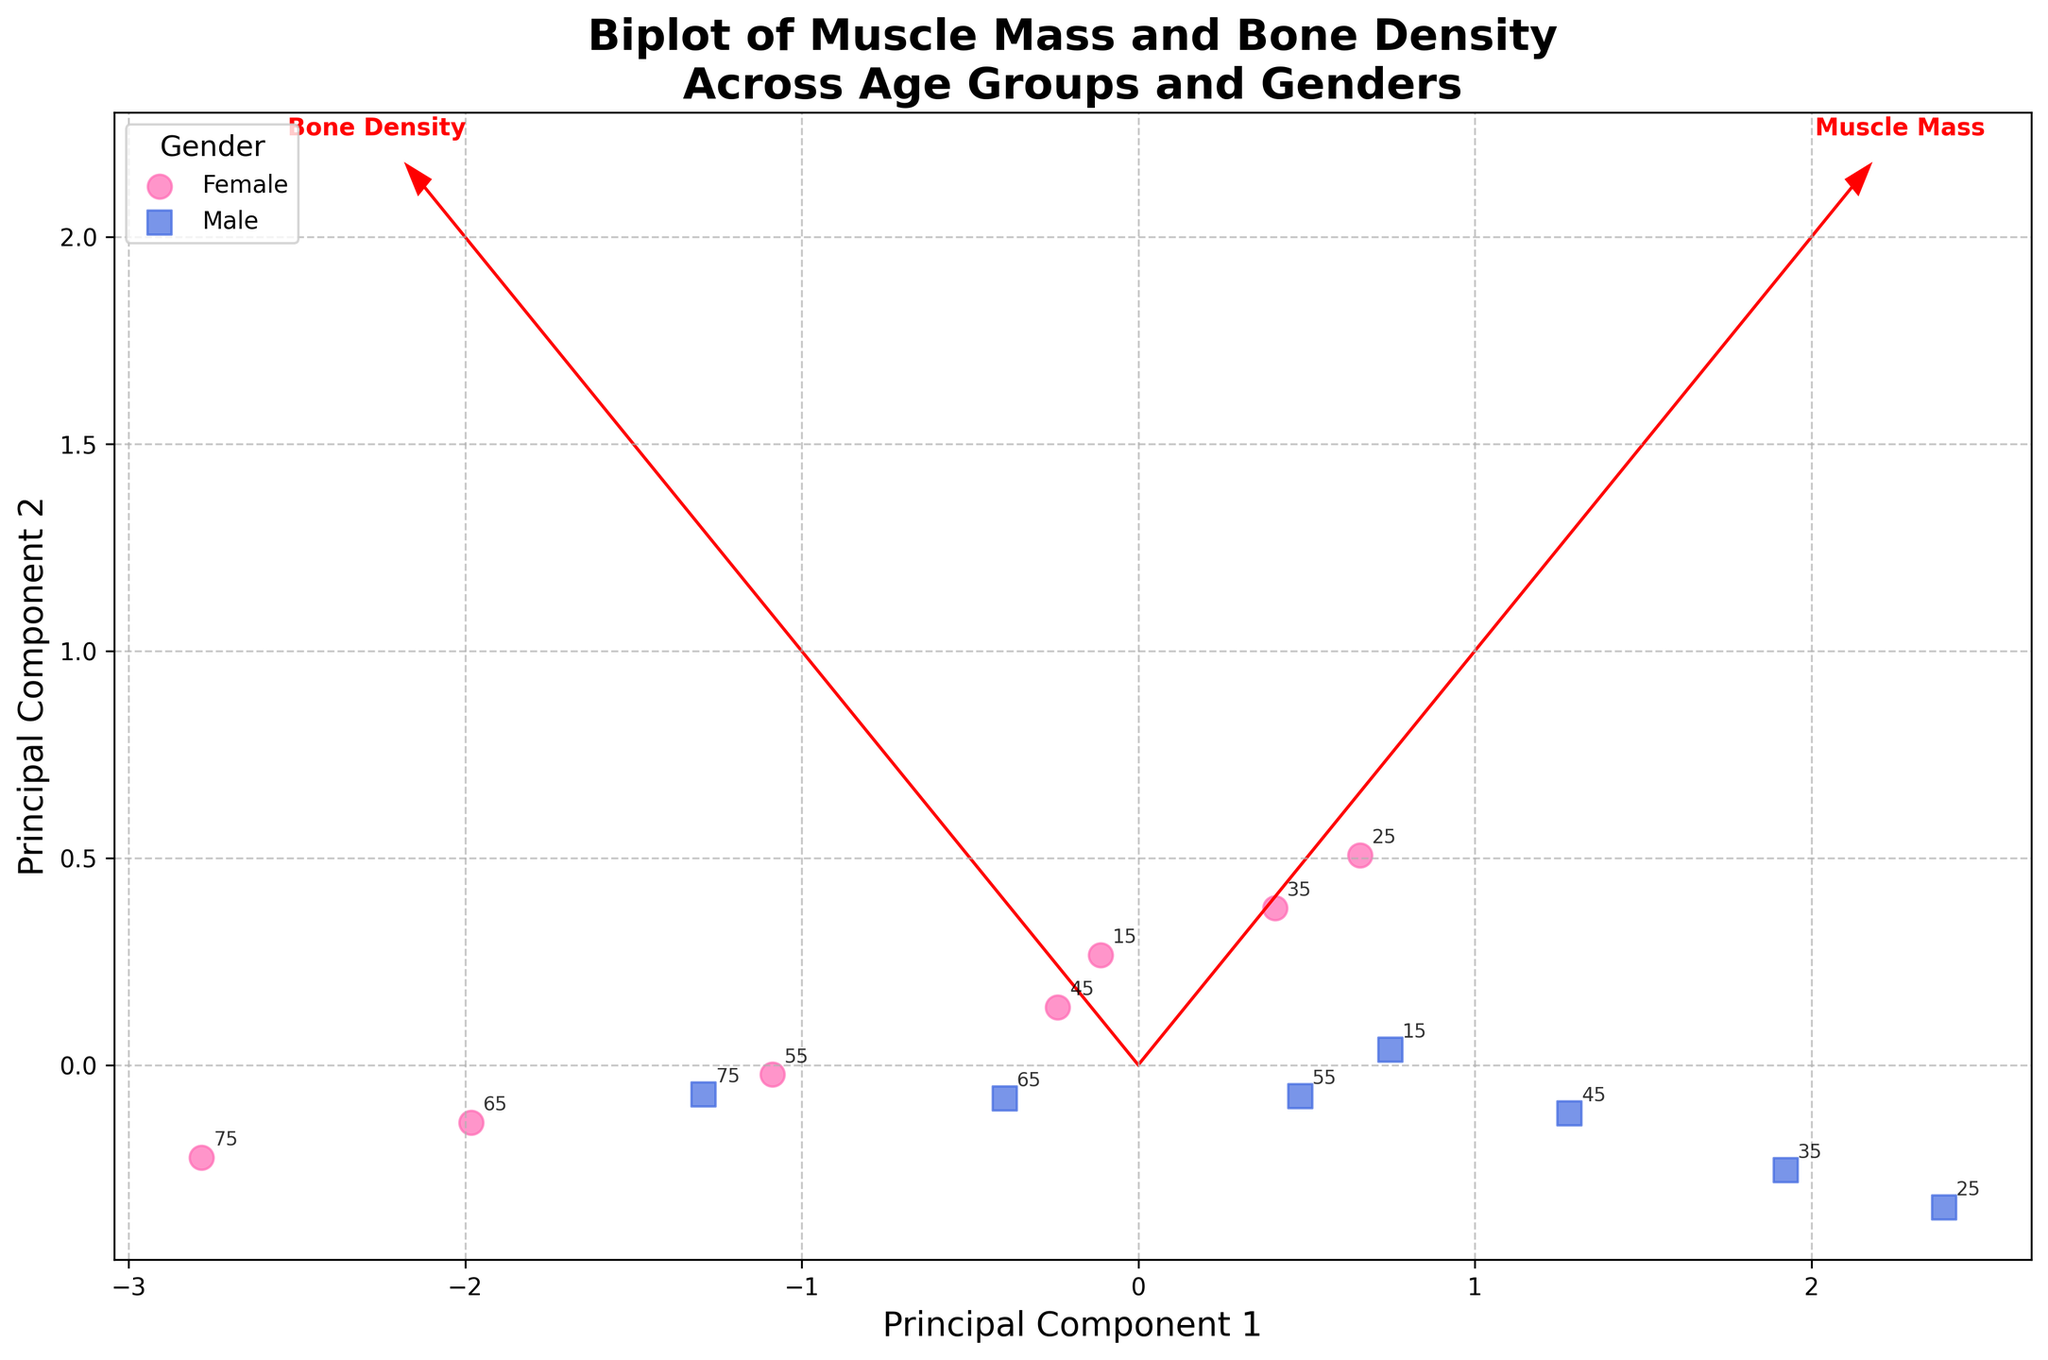How many data points are plotted for each gender? The plot shows data points for both Female and Male categories. To determine the numbers, count the individual markers for each gender shown on the scatter plot.
Answer: 7 points for Female, 7 points for Male What does the horizontal axis represent in this biplot? The horizontal axis is labeled 'Principal Component 1', which represents the first principal component from the PCA analysis. It captures the greatest variance in the data along the x-axis.
Answer: Principal Component 1 Which feature vectors are shown as arrows in the plot? There are two arrows in the plot indicating feature vectors. These are labeled near the tips of the arrows, representing 'Muscle Mass' and 'Bone Density' respectively.
Answer: Muscle Mass and Bone Density What trend can you observe in muscle mass percentage and bone density between genders? The relative positioning of Female and Male data points indicates that Males generally have higher muscle mass percentages and bone densities compared to Females. This trend is visible in the biplot where Male markers are distributed towards higher PC1 and PC2 values.
Answer: Males generally have higher values For the age group 15, which gender has higher bone density according to the plot? By identifying the data points labeled with age 15, compare the positions of Female and Male markers within that age group along the vertical axis, which is Principal Component 2 (related to Bone Density).
Answer: Male What can you infer about the relationship between Muscle Mass and Bone Density features in this dataset? The feature vectors (arrows) indicate the direction and strength of their correlation. Since the arrows for 'Muscle Mass' and 'Bone Density' point in roughly the same direction, it suggests a positive correlation between the two features in the dataset.
Answer: Positive correlation How does the variance captured by Principal Component 1 compare to Principal Component 2? While the exact variance percentages are not given, we typically assume that Principal Component 1 captures more variance than Principal Component 2 from PCA analysis. This assumption is based on standard PCA practices.
Answer: PC1 captures more variance Are there any overlapping data points between different gender within the same age group? By observing the scatterpoints for each gender, check ages listed next to the data points to see if markers from different genders are positioned at the same or very close locations indicating overlap.
Answer: Yes, there are overlaps What is the trend in bone density as age increases for Females? Looking at the Female data points and their positions along the vertical axis (PC2), it is noticeable that bone density decreases with age, as points for older ages are located lower on the PC2 axis.
Answer: Bone density decreases with age Which feature contributes more to Principal Component 2? By examining the direction and length of the arrows, 'Bone Density' likely contributes more to Principal Component 2 as its arrow aligns closely with the vertical axis (PC2).
Answer: Bone Density 